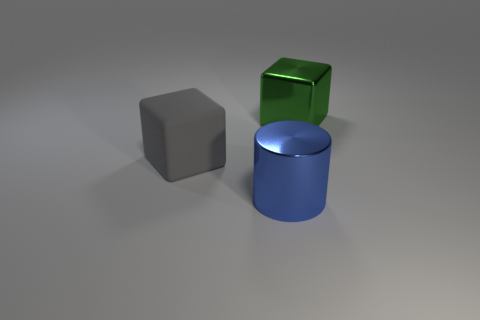What impressions do you get from the overall composition of this image? The image has a minimalist composition that conveys a sense of simplicity and order. The placement of the objects with ample negative space around them emphasizes their shapes and textures, and the neutral background ensures that the viewer's focus remains on the objects themselves. 